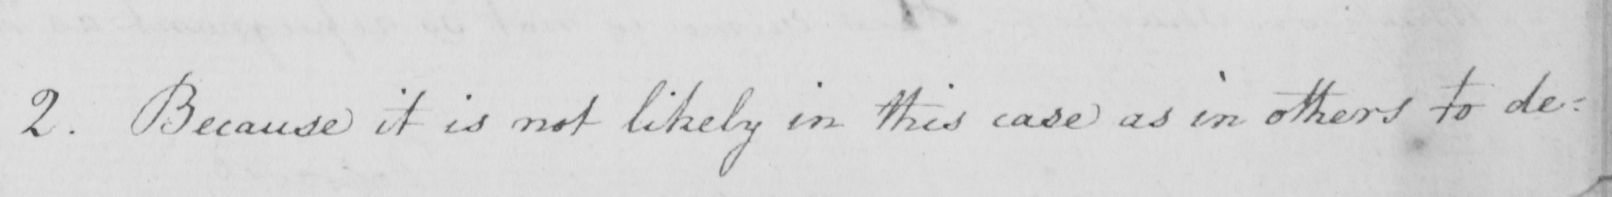What is written in this line of handwriting? 2 . Because it is not likely in this case as in others to de= 